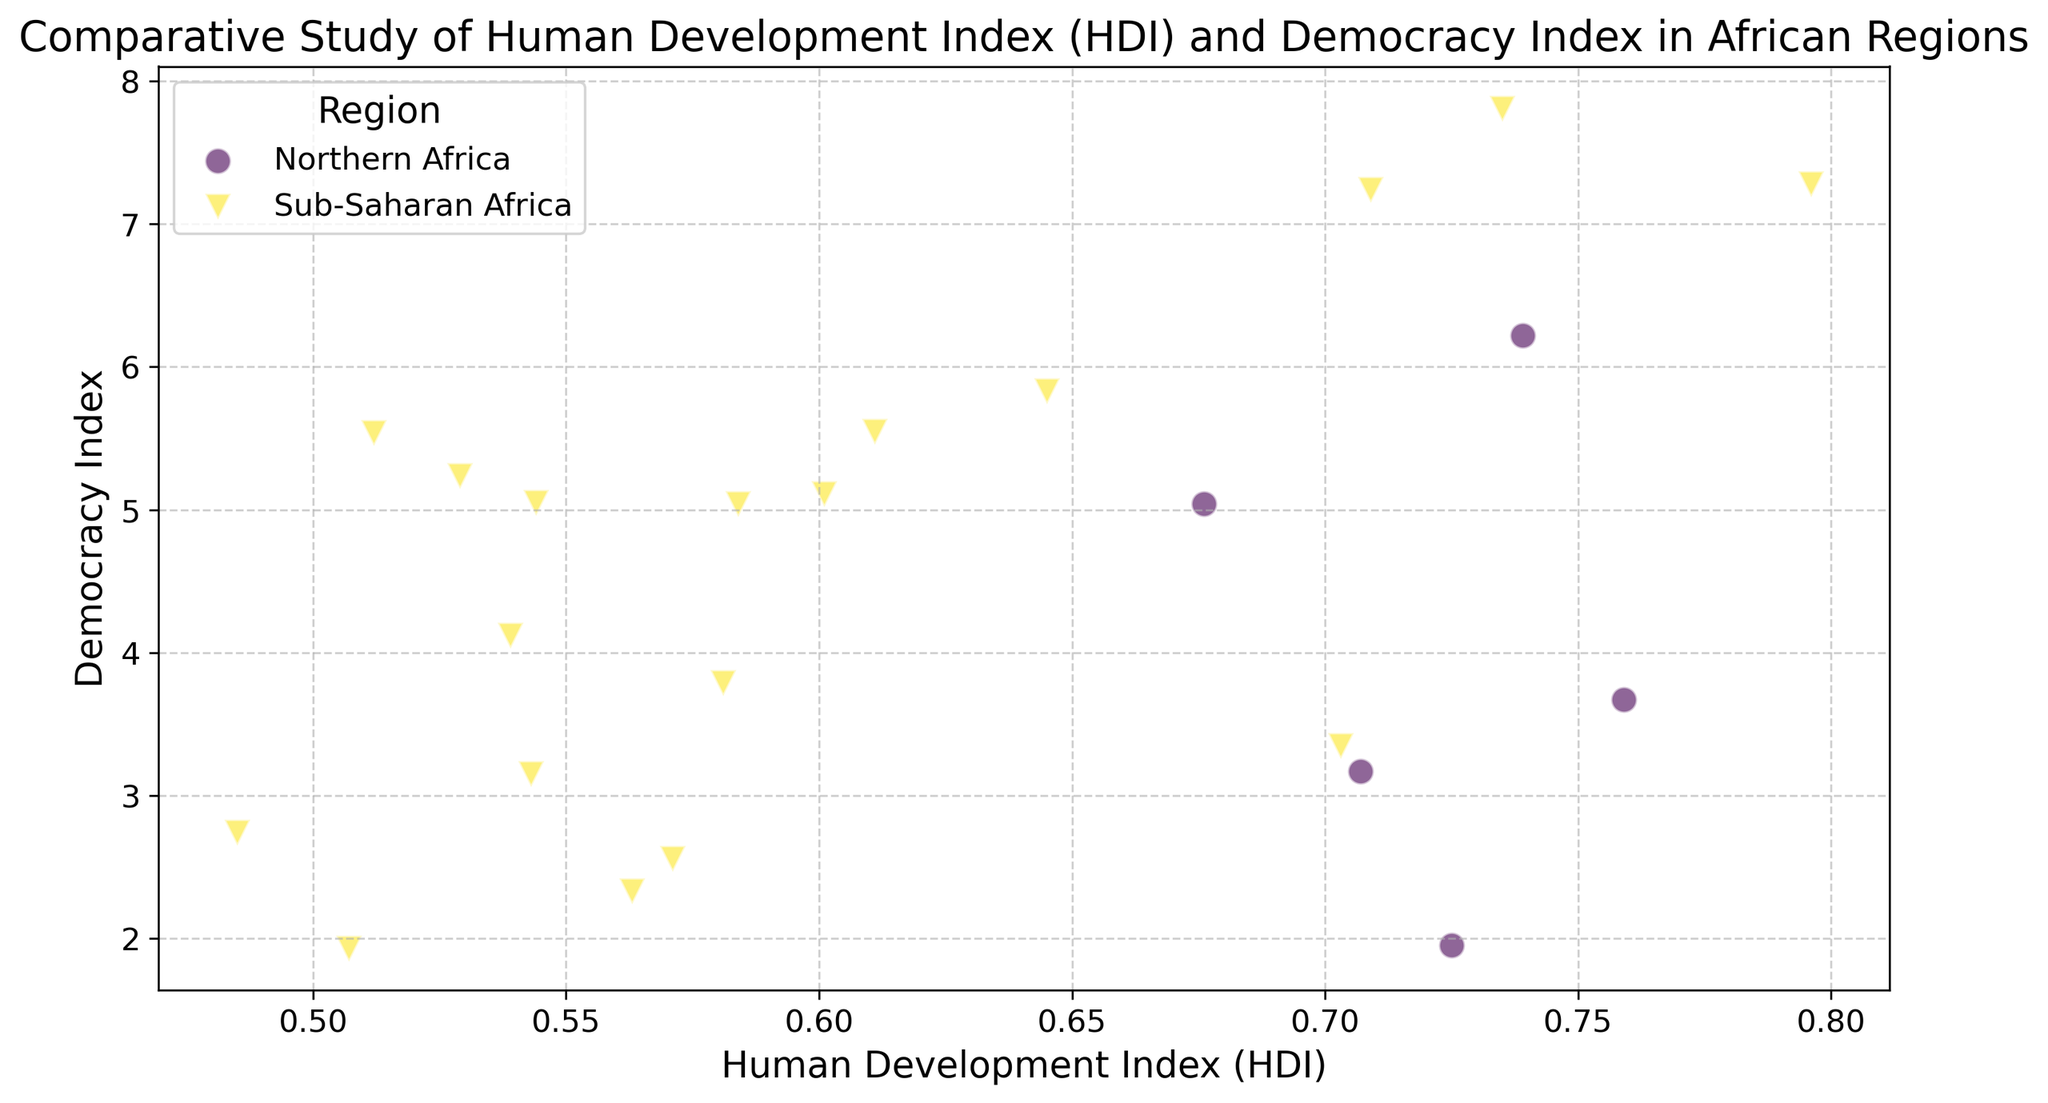Which country in Sub-Saharan Africa has the highest Democracy Index? First, locate the data points representing Sub-Saharan Africa. Then, identify the highest point on the Democracy Index axis within these data points.
Answer: Botswana Which region has the widest range of HDI values? Compare the span of HDI values for each region by looking at the left-most and right-most data points within each region.
Answer: Sub-Saharan Africa What is the average HDI of Northern African countries? Extract the HDI values for all Northern African countries, then sum them up and divide by the number of countries. The values are 0.759 (Algeria), 0.707 (Egypt), 0.725 (Libya), 0.676 (Morocco), and 0.739 (Tunisia). Their sum is 3.606, and there are 5 countries. Calculate 3.606/5.
Answer: 0.721 Which country has the lowest Democracy Index, and which region does it belong to? Identify the lowest point on the Democracy Index axis and note its corresponding country and region.
Answer: Sudan, Sub-Saharan Africa Comparing Egypt and Tunisia, which country has a higher HDI and by how much? Identify the HDI values for Egypt (0.707) and Tunisia (0.739), then subtract the smaller value from the larger one.
Answer: Tunisia by 0.032 Is there a correlation between HDI and Democracy Index in the plot? Observe the overall trend of the data points; if the points generally move from lower left to upper right, it suggests a positive correlation. If there's no clear trend, the correlation might be weak or nonexistent.
Answer: Not clear/weak Which region has the highest average Democracy Index? Calculate the average Democracy Index for each region by summing the Democracy Index values of all countries within that region and dividing by the number of countries. Compare the resulting averages for each region.
Answer: Sub-Saharan Africa What is the HDI value of the country with the highest Democracy Index? Identify the highest point on the Democracy Index axis, then note its corresponding HDI value. The highest Democracy Index is Botswana with 7.81, and it corresponds to an HDI of 0.735.
Answer: 0.735 What is the overall range of Democracy Index values? Subtract the smallest Democracy Index value from the largest one observed in the plot. The smallest value is 1.93 (Sudan), and the largest is 7.81 (Botswana). The range is 7.81 - 1.93.
Answer: 5.88 Which two countries from different regions have the closest HDI values? Compare the HDI values across different regions and identify the closest pair. For instance, looking at Northern Africa and Sub-Saharan Africa, Egypt (0.707) and South Africa (0.709) have very close HDI values (difference of 0.002).
Answer: Egypt and South Africa (difference of 0.002) 